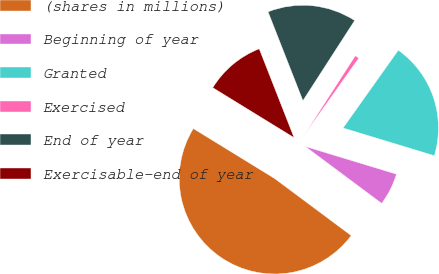Convert chart to OTSL. <chart><loc_0><loc_0><loc_500><loc_500><pie_chart><fcel>(shares in millions)<fcel>Beginning of year<fcel>Granted<fcel>Exercised<fcel>End of year<fcel>Exercisable-end of year<nl><fcel>48.58%<fcel>5.5%<fcel>19.86%<fcel>0.71%<fcel>15.07%<fcel>10.28%<nl></chart> 